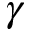<formula> <loc_0><loc_0><loc_500><loc_500>\gamma</formula> 